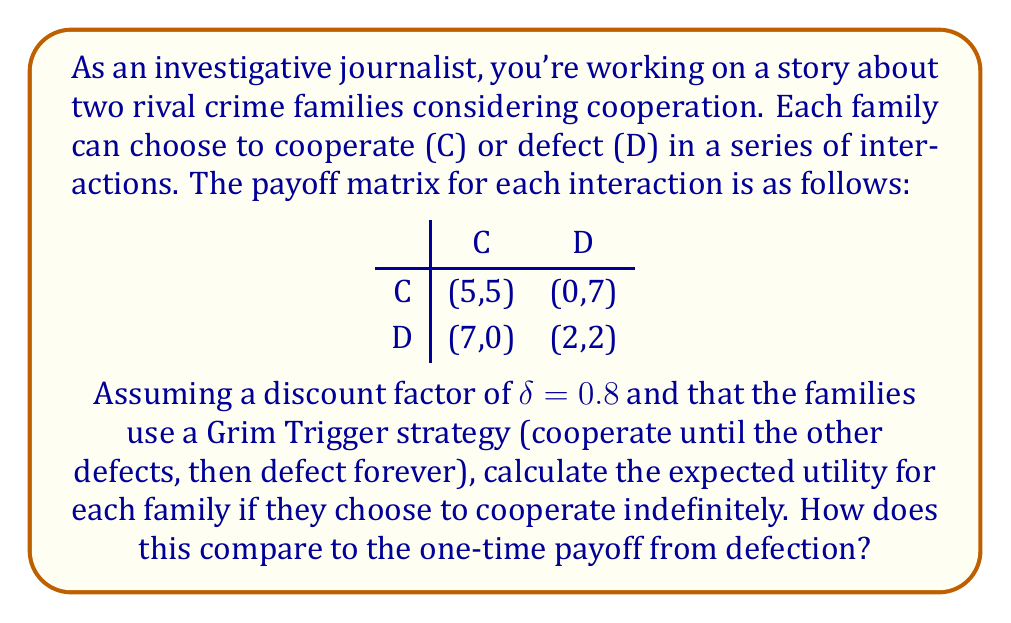Give your solution to this math problem. To solve this problem, we need to consider the repeated game scenario and calculate the expected utility of cooperation versus defection.

1. Expected utility of cooperation:
   If both families cooperate indefinitely, they will receive a payoff of 5 in each round. The expected utility can be calculated using the formula for an infinite geometric series:

   $$EU_{coop} = 5 + 5\delta + 5\delta^2 + 5\delta^3 + ... = \frac{5}{1-\delta}$$

   Substituting $\delta = 0.8$:
   $$EU_{coop} = \frac{5}{1-0.8} = \frac{5}{0.2} = 25$$

2. Utility of defection:
   If a family chooses to defect, they will receive a one-time payoff of 7, but then both families will defect in all future rounds, resulting in a payoff of 2 per round. The expected utility of defection is:

   $$EU_{defect} = 7 + 2\delta + 2\delta^2 + 2\delta^3 + ... = 7 + \frac{2\delta}{1-\delta}$$

   Substituting $\delta = 0.8$:
   $$EU_{defect} = 7 + \frac{2(0.8)}{1-0.8} = 7 + \frac{1.6}{0.2} = 7 + 8 = 15$$

3. Comparison:
   The expected utility of cooperation (25) is greater than the expected utility of defection (15), indicating that in this repeated game scenario, it is more beneficial for the crime families to cooperate indefinitely rather than to defect.
Answer: The expected utility of cooperation for each family is 25, which is greater than the expected utility of defection (15). Therefore, in this repeated game scenario with a Grim Trigger strategy and a discount factor of 0.8, it is more beneficial for the crime families to cooperate indefinitely rather than to defect. 